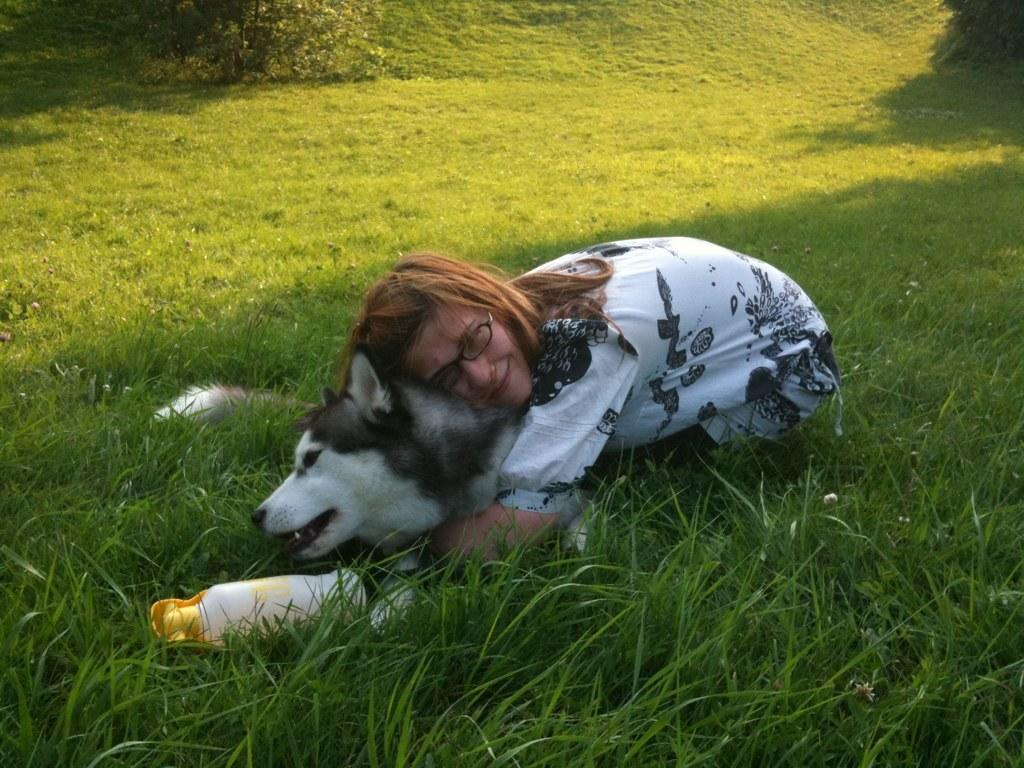What color is the grass in the image? The grass is green in color. What is the woman doing in the image? The woman is holding a dog on the grass. What object is in front of the dog? There is a bottle in front of the dog. What type of salt can be seen on the grass in the image? There is no salt present on the grass in the image. Are there any bushes visible in the image? The provided facts do not mention any bushes in the image. 